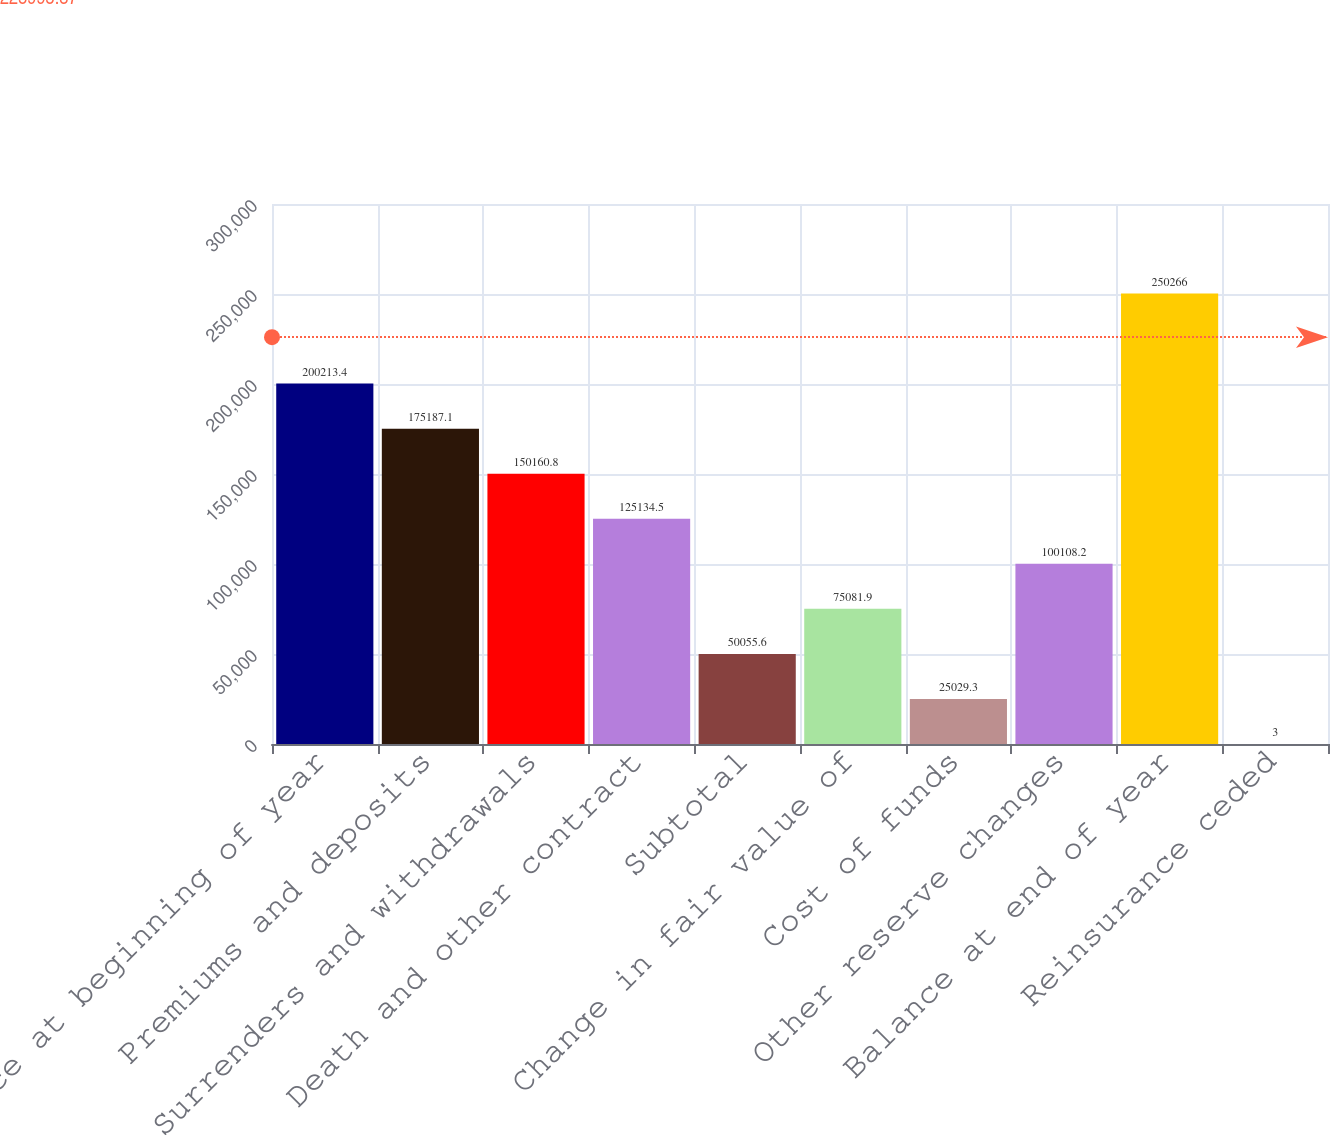Convert chart. <chart><loc_0><loc_0><loc_500><loc_500><bar_chart><fcel>Balance at beginning of year<fcel>Premiums and deposits<fcel>Surrenders and withdrawals<fcel>Death and other contract<fcel>Subtotal<fcel>Change in fair value of<fcel>Cost of funds<fcel>Other reserve changes<fcel>Balance at end of year<fcel>Reinsurance ceded<nl><fcel>200213<fcel>175187<fcel>150161<fcel>125134<fcel>50055.6<fcel>75081.9<fcel>25029.3<fcel>100108<fcel>250266<fcel>3<nl></chart> 